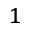<formula> <loc_0><loc_0><loc_500><loc_500>^ { 1 }</formula> 